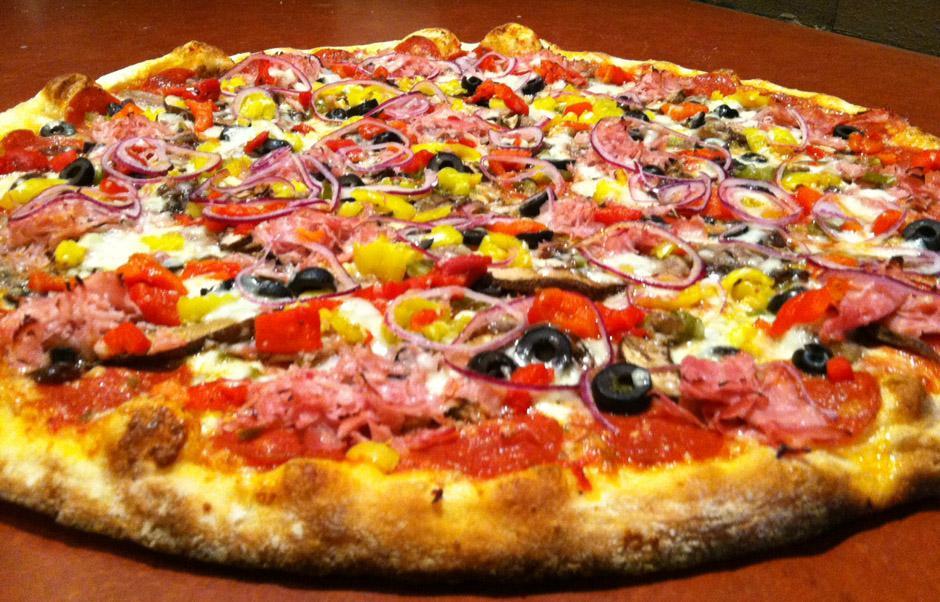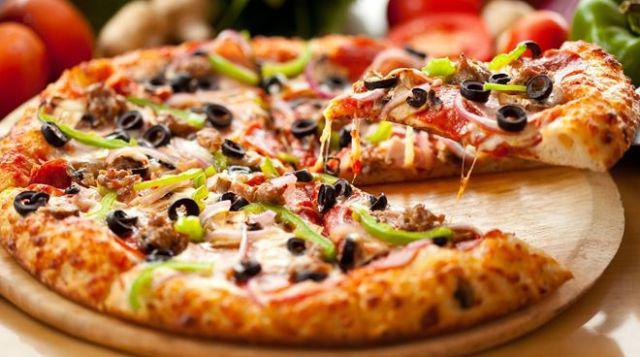The first image is the image on the left, the second image is the image on the right. Analyze the images presented: Is the assertion "The pizza in one of the images is placed on a metal baking pan." valid? Answer yes or no. No. 